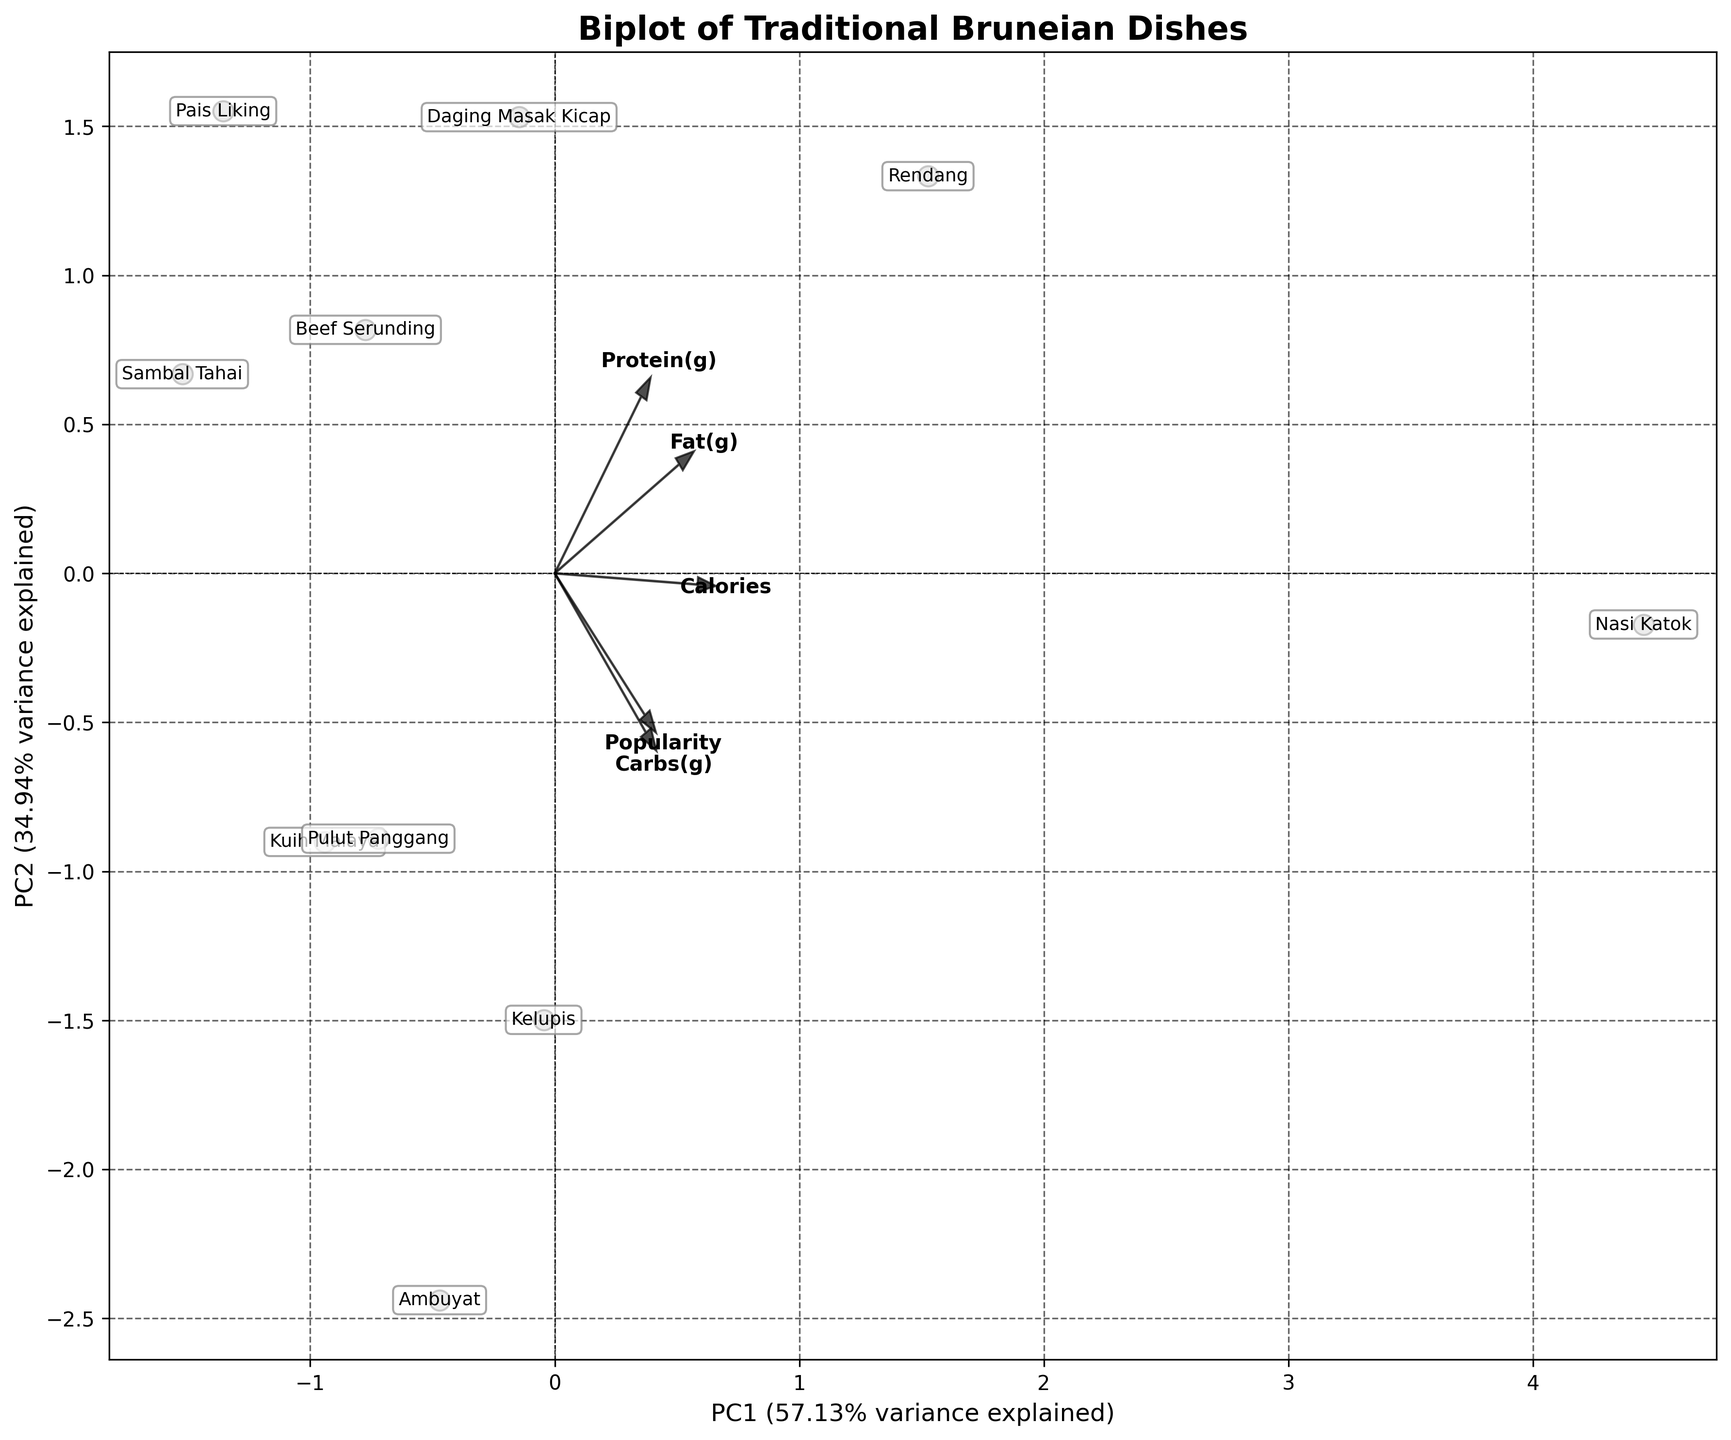What's the title of the figure? The title is usually displayed prominently at the top of the figure. Look at the text that is bold and larger than the rest.
Answer: Biplot of Traditional Bruneian Dishes How many data points are there in the plot? The number of data points corresponds to the number of labeled dish names spread throughout the plot. Count each labeled point.
Answer: 10 Which dish appears to be the most popular? Popularity is a feature displayed by the direction and length of the vectors in the biplot. Look for the dish closest to the "Popularity" arrow.
Answer: Ambuyat What does the x-axis represent? The x-axis typically lists the principal component (PC1) and the percentage of the variance it explains. Look at the axis label for this information.
Answer: PC1 (with a percentage of variance explained) Which dish has the highest contribution of protein? Protein contribution can be inferred by analyzing the proximity of the dishes to the "Protein(g)" vector. Find the dish closest to this vector.
Answer: Nasi Katok Compare the Calories and Fat vectors; which dish is highest in both aspects? Look at the data points that are positioned directionally near and between both the "Calories" and "Fat(g)" vectors.
Answer: Nasi Katok Which vectors appear to point in a similar direction? By comparing the directions of the arrows, observe the vectors that are closely aligned or pointing towards the same quadrant.
Answer: Calories and Carbs(g) What percentage of the variance is explained by PC2? This information is displayed on the y-axis label, which typically lists PC2 and the percentage of variance it accounts for.
Answer: (around) 17% How are Pulut Panggang and Sambal Tahai similar or different in their nutritional profile? Examine the position of both Pulut Panggang and Sambal Tahai in relation to the feature vectors and note the differences in distance to each vector, indicating the nutritional content similarity or difference.
Answer: Similar in Protein(g), different in Carbs(g) and Fat(g) Which dish is located furthest away from the origin (0,0)? The dish furthest from the origin point (intersection of the axes) is the one whose data point is the most distant from the center of the plot.
Answer: Nasi Katok 